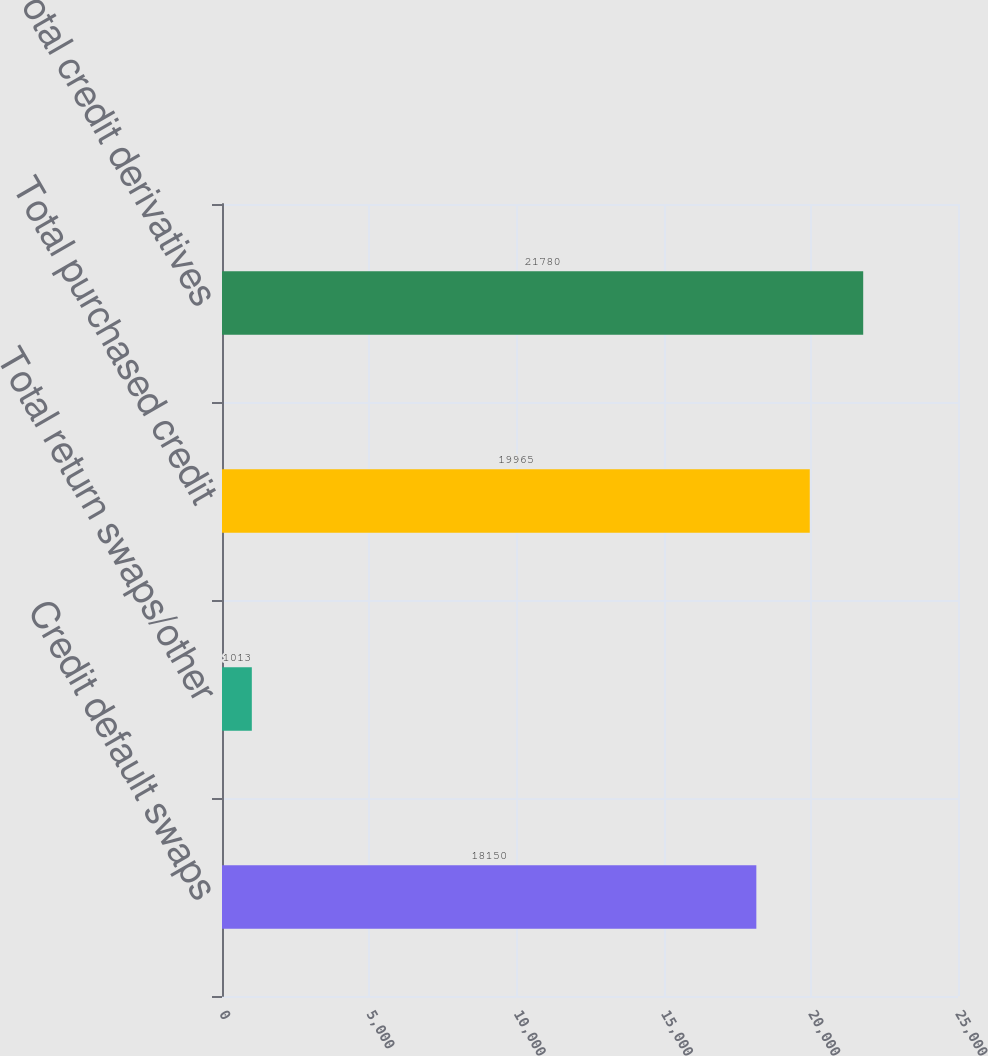<chart> <loc_0><loc_0><loc_500><loc_500><bar_chart><fcel>Credit default swaps<fcel>Total return swaps/other<fcel>Total purchased credit<fcel>Total credit derivatives<nl><fcel>18150<fcel>1013<fcel>19965<fcel>21780<nl></chart> 